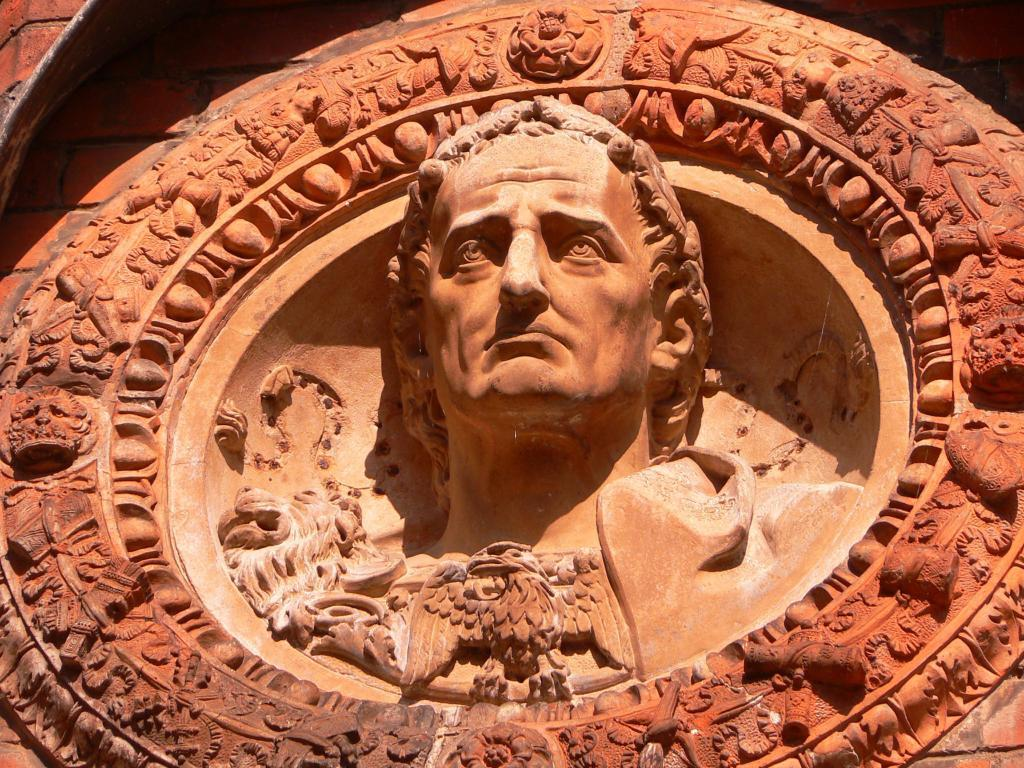What is the main subject of the image? There is a sculpture of a person in the image. What is the color of the sculpture? The sculpture is in light orange color. What type of oatmeal is being served in the image? There is no oatmeal present in the image; it features a sculpture of a person in light orange color. 